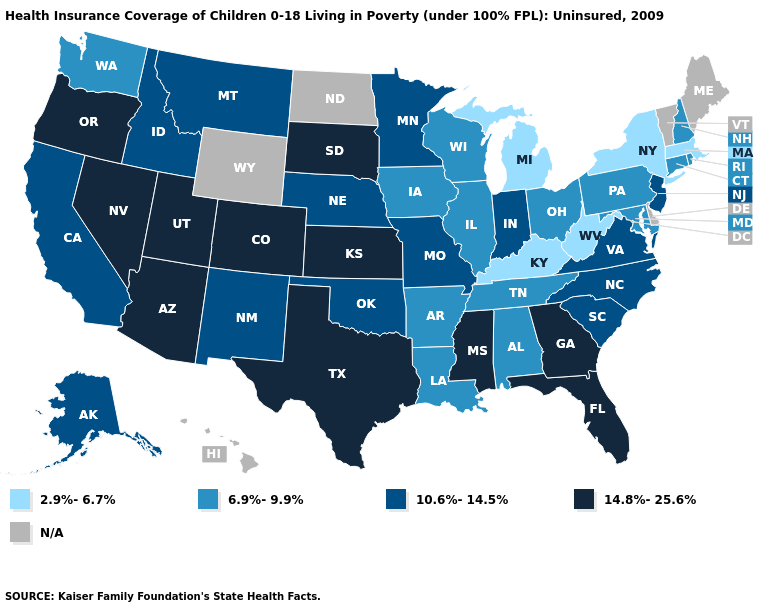Is the legend a continuous bar?
Quick response, please. No. Name the states that have a value in the range 10.6%-14.5%?
Quick response, please. Alaska, California, Idaho, Indiana, Minnesota, Missouri, Montana, Nebraska, New Jersey, New Mexico, North Carolina, Oklahoma, South Carolina, Virginia. What is the value of Connecticut?
Concise answer only. 6.9%-9.9%. What is the highest value in states that border New Mexico?
Answer briefly. 14.8%-25.6%. Name the states that have a value in the range 14.8%-25.6%?
Short answer required. Arizona, Colorado, Florida, Georgia, Kansas, Mississippi, Nevada, Oregon, South Dakota, Texas, Utah. Name the states that have a value in the range N/A?
Concise answer only. Delaware, Hawaii, Maine, North Dakota, Vermont, Wyoming. What is the value of Florida?
Answer briefly. 14.8%-25.6%. What is the value of Mississippi?
Short answer required. 14.8%-25.6%. What is the value of Utah?
Concise answer only. 14.8%-25.6%. Which states have the highest value in the USA?
Give a very brief answer. Arizona, Colorado, Florida, Georgia, Kansas, Mississippi, Nevada, Oregon, South Dakota, Texas, Utah. Does Florida have the highest value in the USA?
Keep it brief. Yes. Name the states that have a value in the range N/A?
Give a very brief answer. Delaware, Hawaii, Maine, North Dakota, Vermont, Wyoming. Name the states that have a value in the range 2.9%-6.7%?
Be succinct. Kentucky, Massachusetts, Michigan, New York, West Virginia. What is the value of South Carolina?
Be succinct. 10.6%-14.5%. Name the states that have a value in the range 14.8%-25.6%?
Short answer required. Arizona, Colorado, Florida, Georgia, Kansas, Mississippi, Nevada, Oregon, South Dakota, Texas, Utah. 